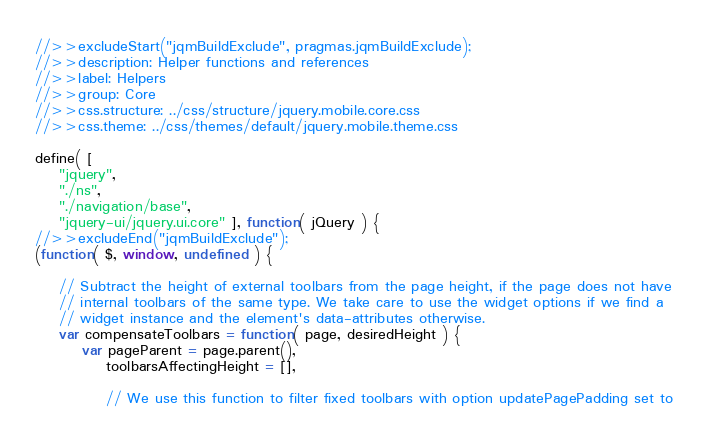Convert code to text. <code><loc_0><loc_0><loc_500><loc_500><_JavaScript_>//>>excludeStart("jqmBuildExclude", pragmas.jqmBuildExclude);
//>>description: Helper functions and references
//>>label: Helpers
//>>group: Core
//>>css.structure: ../css/structure/jquery.mobile.core.css
//>>css.theme: ../css/themes/default/jquery.mobile.theme.css

define( [
	"jquery",
	"./ns",
	"./navigation/base",
	"jquery-ui/jquery.ui.core" ], function( jQuery ) {
//>>excludeEnd("jqmBuildExclude");
(function( $, window, undefined ) {

	// Subtract the height of external toolbars from the page height, if the page does not have
	// internal toolbars of the same type. We take care to use the widget options if we find a
	// widget instance and the element's data-attributes otherwise.
	var compensateToolbars = function( page, desiredHeight ) {
		var pageParent = page.parent(),
			toolbarsAffectingHeight = [],

			// We use this function to filter fixed toolbars with option updatePagePadding set to</code> 